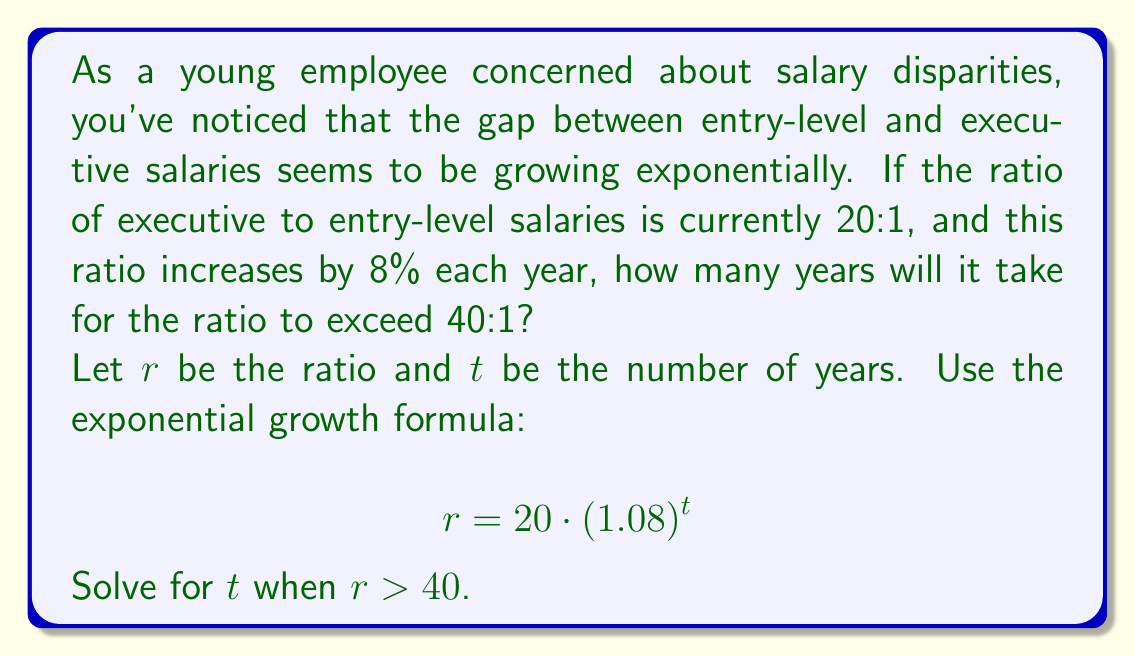Can you solve this math problem? To solve this problem, we'll use the exponential growth formula and logarithms:

1) Set up the inequality:
   $$20 \cdot (1.08)^t > 40$$

2) Divide both sides by 20:
   $$(1.08)^t > 2$$

3) Take the natural logarithm of both sides:
   $$\ln((1.08)^t) > \ln(2)$$

4) Use the logarithm property $\ln(a^b) = b\ln(a)$:
   $$t \cdot \ln(1.08) > \ln(2)$$

5) Divide both sides by $\ln(1.08)$:
   $$t > \frac{\ln(2)}{\ln(1.08)}$$

6) Calculate the right-hand side:
   $$t > \frac{0.6931471806}{0.0769610411} \approx 9.0060$$

7) Since $t$ must be a whole number of years, we round up to the next integer.
Answer: It will take 10 years for the salary ratio to exceed 40:1. 